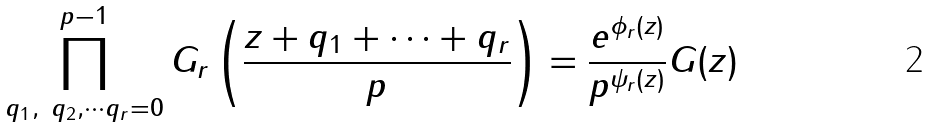Convert formula to latex. <formula><loc_0><loc_0><loc_500><loc_500>\prod _ { q _ { 1 } , \ q _ { 2 } , \cdots q _ { r } = 0 } ^ { p - 1 } G _ { r } \left ( \frac { z + q _ { 1 } + \cdots + q _ { r } } { p } \right ) = \frac { e ^ { \phi _ { r } ( z ) } } { p ^ { \psi _ { r } ( z ) } } G ( z )</formula> 